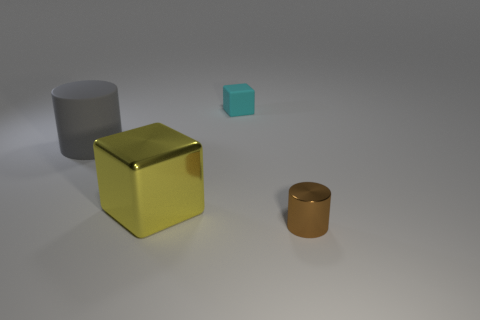There is a gray cylinder; does it have the same size as the metal object that is on the left side of the tiny brown metal cylinder?
Provide a succinct answer. Yes. What number of things are objects that are on the left side of the brown metallic cylinder or cylinders that are on the left side of the brown cylinder?
Your answer should be very brief. 3. The cyan rubber thing that is the same size as the metal cylinder is what shape?
Your response must be concise. Cube. What is the shape of the big matte thing that is on the left side of the cylinder in front of the rubber thing that is to the left of the small cyan object?
Keep it short and to the point. Cylinder. Is the number of small metal things behind the small cyan matte object the same as the number of green blocks?
Your response must be concise. Yes. Is the size of the metallic cube the same as the cyan matte object?
Make the answer very short. No. What number of matte things are small cyan cubes or large gray cylinders?
Your answer should be very brief. 2. There is a yellow block that is the same size as the rubber cylinder; what is it made of?
Offer a very short reply. Metal. How many other things are there of the same material as the yellow block?
Offer a terse response. 1. Is the number of small brown metal objects that are on the left side of the large metal cube less than the number of tiny blue things?
Offer a very short reply. No. 